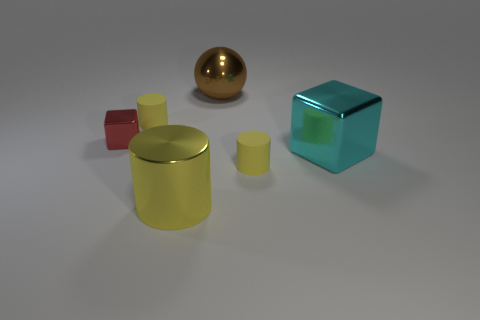Add 1 green metallic blocks. How many objects exist? 7 Subtract all cubes. How many objects are left? 4 Add 6 big cyan metal cubes. How many big cyan metal cubes exist? 7 Subtract 0 red spheres. How many objects are left? 6 Subtract all large cyan rubber blocks. Subtract all red things. How many objects are left? 5 Add 3 small yellow cylinders. How many small yellow cylinders are left? 5 